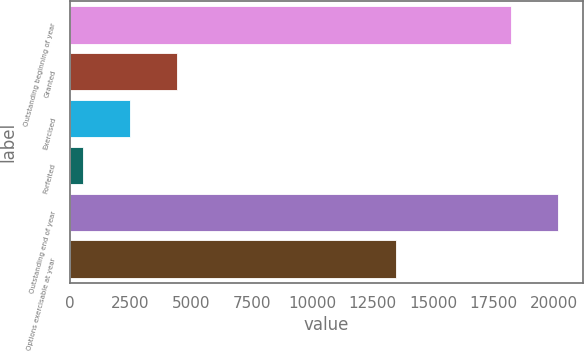Convert chart. <chart><loc_0><loc_0><loc_500><loc_500><bar_chart><fcel>Outstanding beginning of year<fcel>Granted<fcel>Exercised<fcel>Forfeited<fcel>Outstanding end of year<fcel>Options exercisable at year<nl><fcel>18237<fcel>4420<fcel>2487<fcel>554<fcel>20170<fcel>13471<nl></chart> 